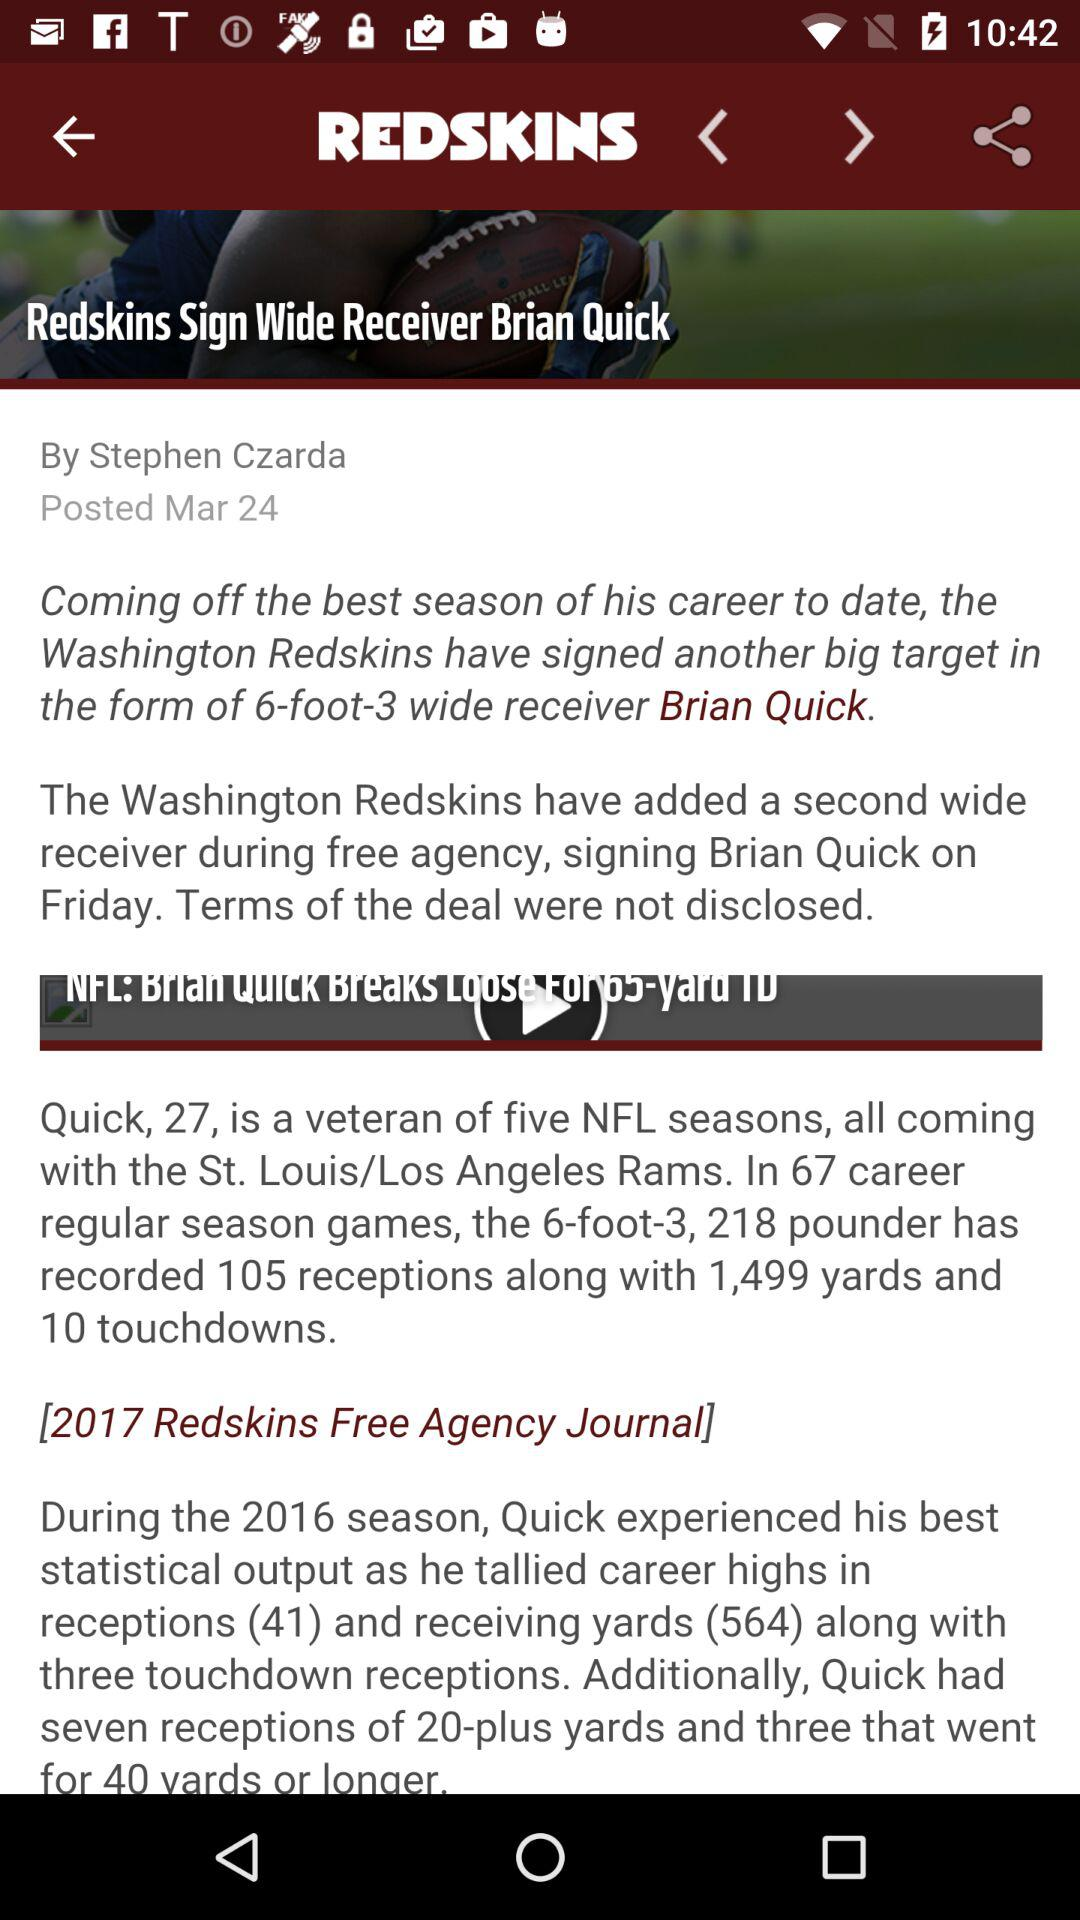Who posted the news "Redskins Sign Wide Receiver Brian Quick"? It was posted by Stephen Czarda. 